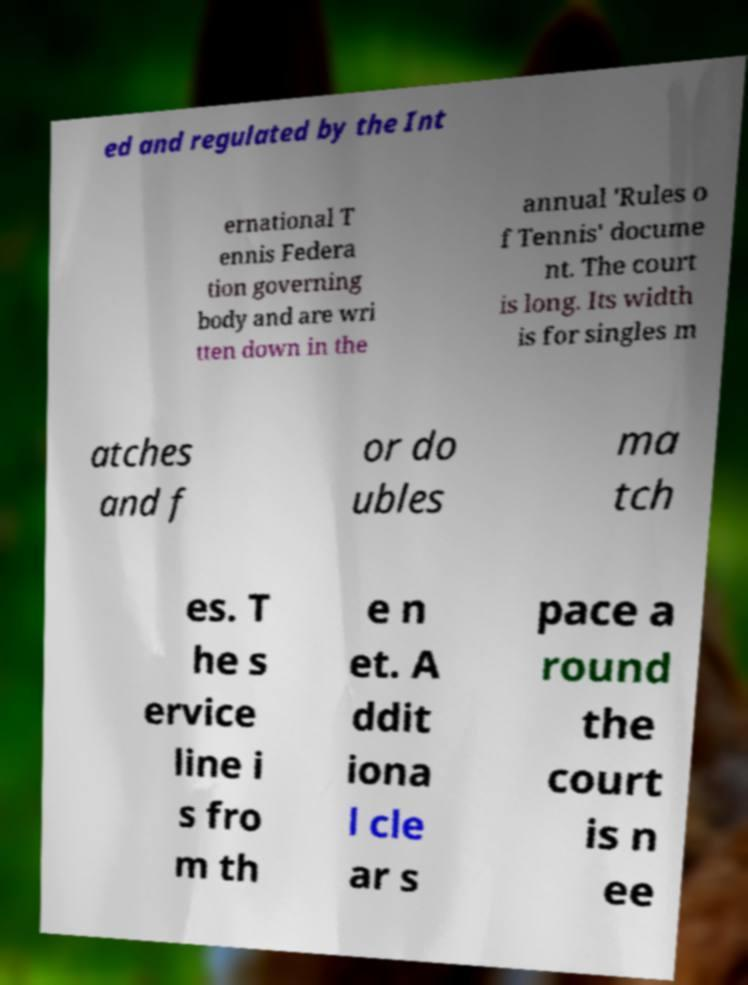What messages or text are displayed in this image? I need them in a readable, typed format. ed and regulated by the Int ernational T ennis Federa tion governing body and are wri tten down in the annual 'Rules o f Tennis' docume nt. The court is long. Its width is for singles m atches and f or do ubles ma tch es. T he s ervice line i s fro m th e n et. A ddit iona l cle ar s pace a round the court is n ee 